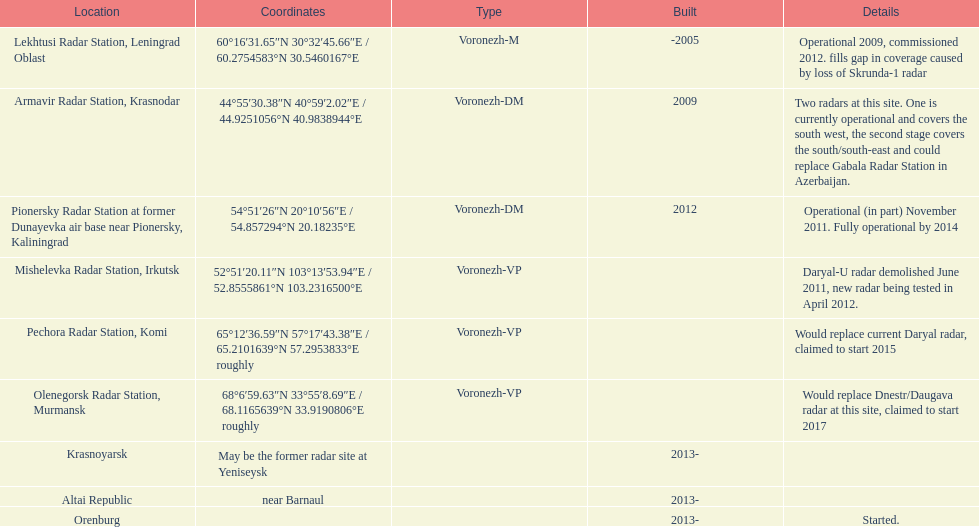How many voronezh radars were built before 2010? 2. 